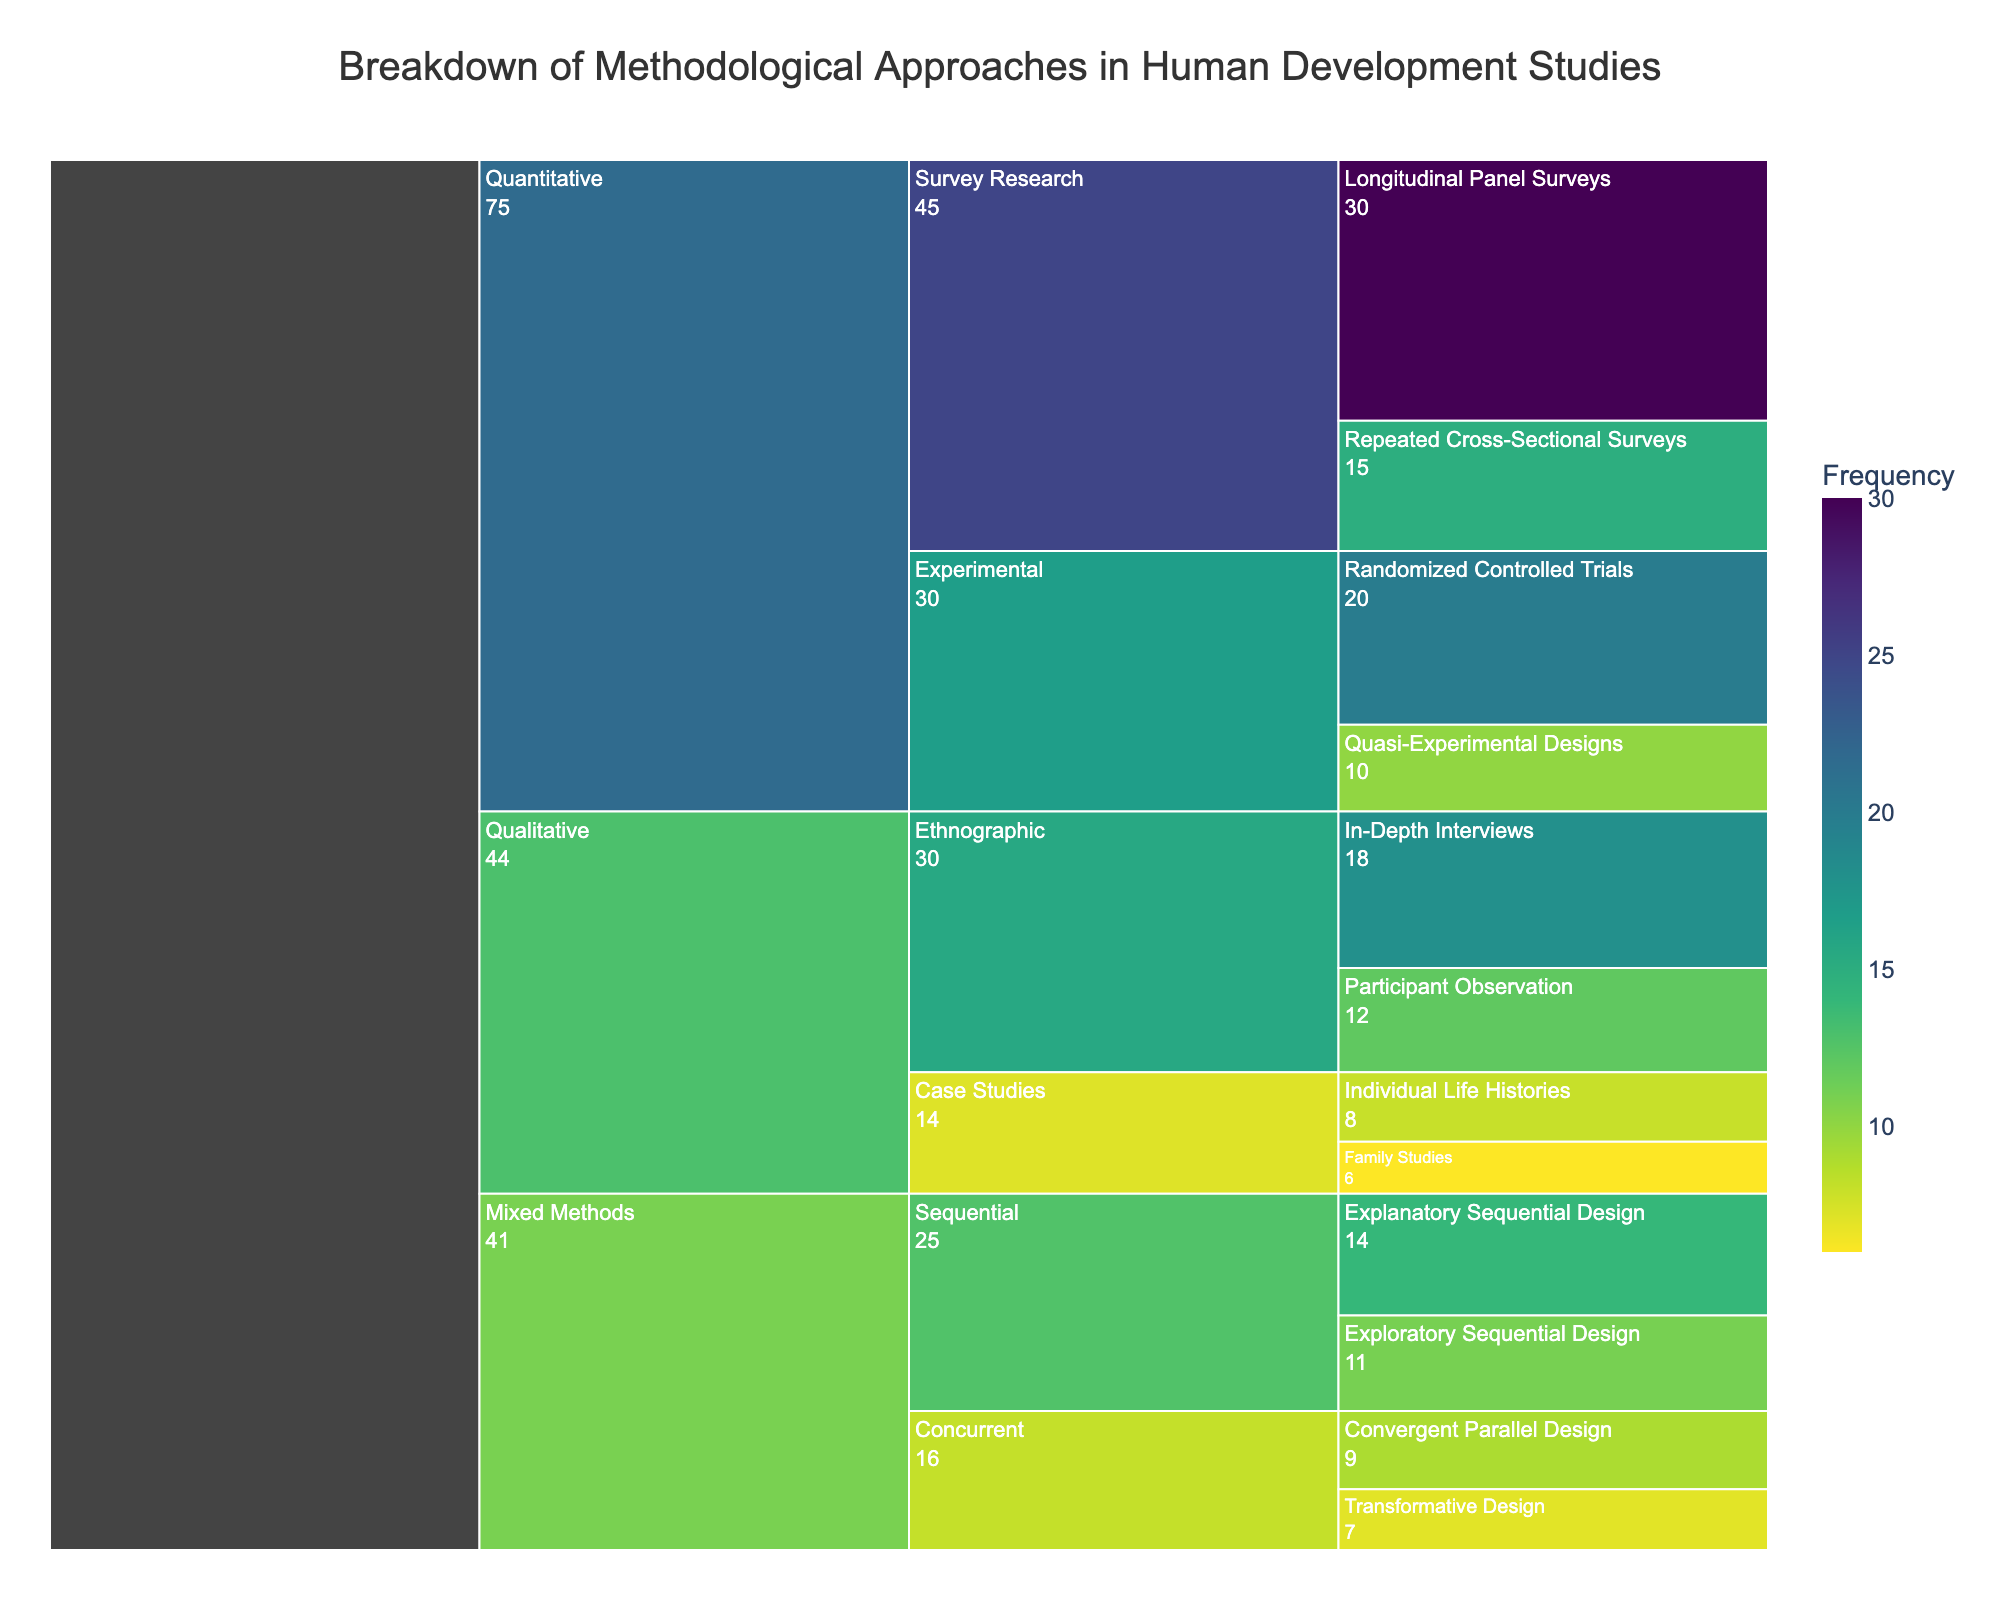What's the title of the chart? The title is usually at the top of the chart and provides a summary of what the chart represents. In this case, the title should be visible at the top center.
Answer: Breakdown of Methodological Approaches in Human Development Studies What methodological approach has the highest frequency? To find the highest frequency, look for the value that is the largest in the chart. The label associated with that value will indicate the approach.
Answer: Longitudinal Panel Surveys How many subcategories are there within the Quantitative category? The Quantitative category can be expanded to see its subcategories. Count how many distinct subcategories are present.
Answer: 2 Which mixed methods subcategory has the greater total frequency, Sequential or Concurrent? Sum up the frequencies of the methods within each mixed methods subcategory (Sequential: Explanatory Sequential Design, Exploratory Sequential Design; Concurrent: Convergent Parallel Design, Transformative Design) and compare them.
Answer: Sequential What is the combined frequency of all Qualitative approaches? Add the frequencies of all methods under the Qualitative category: Participant Observation (12), In-Depth Interviews (18), Individual Life Histories (8), and Family Studies (6).
Answer: 44 Which subcategory within Qualitative has the lowest total frequency? Look at the total frequency for each subcategory within Qualitative: Ethnographic (Participant Observation + In-Depth Interviews) and Case Studies (Individual Life Histories + Family Studies), and compare them.
Answer: Case Studies What's the difference in frequency between Randomized Controlled Trials and Quasi-Experimental Designs? Subtract the frequency of Quasi-Experimental Designs (10) from that of Randomized Controlled Trials (20).
Answer: 10 How does the frequency of Repeated Cross-Sectional Surveys compare to Explanatory Sequential Design? Compare the frequencies directly: Repeated Cross-Sectional Surveys (15) and Explanatory Sequential Design (14).
Answer: Repeated Cross-Sectional Surveys has a higher frequency What percentage of the total methodologies does Participant Observation represent? First, find the total frequency of all approaches by summing all frequencies. Then, divide the frequency of Participant Observation by this total and multiply by 100 to get the percentage.
Answer: 8.34% Is there a subcategory in Quantitative methods where all method frequencies are greater than 10? Check each subcategory within Quantitative (Survey Research and Experimental) to determine if all methods in that subcategory have frequencies greater than 10.
Answer: No 